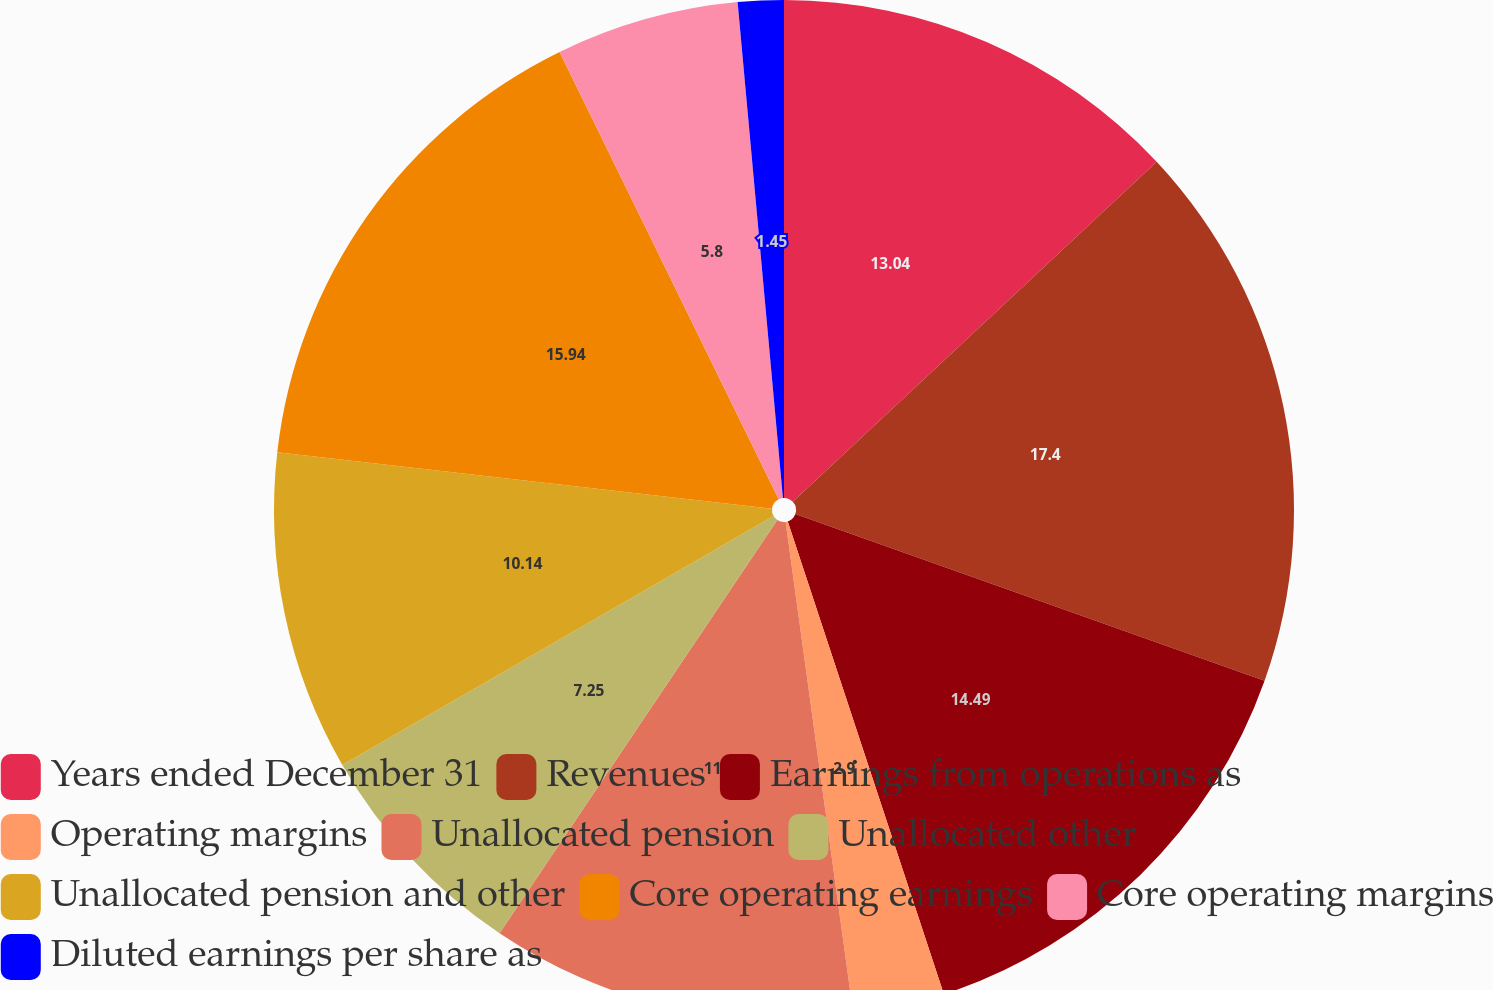<chart> <loc_0><loc_0><loc_500><loc_500><pie_chart><fcel>Years ended December 31<fcel>Revenues<fcel>Earnings from operations as<fcel>Operating margins<fcel>Unallocated pension<fcel>Unallocated other<fcel>Unallocated pension and other<fcel>Core operating earnings<fcel>Core operating margins<fcel>Diluted earnings per share as<nl><fcel>13.04%<fcel>17.39%<fcel>14.49%<fcel>2.9%<fcel>11.59%<fcel>7.25%<fcel>10.14%<fcel>15.94%<fcel>5.8%<fcel>1.45%<nl></chart> 